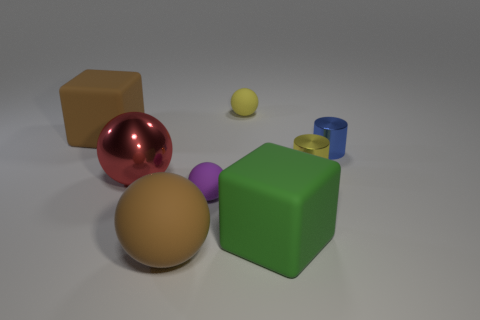Subtract all rubber spheres. How many spheres are left? 1 Subtract all yellow spheres. How many spheres are left? 3 Add 1 purple matte things. How many objects exist? 9 Subtract all green spheres. Subtract all blue cubes. How many spheres are left? 4 Subtract all cubes. How many objects are left? 6 Subtract all red things. Subtract all large red balls. How many objects are left? 6 Add 4 small matte balls. How many small matte balls are left? 6 Add 4 shiny spheres. How many shiny spheres exist? 5 Subtract 0 gray cubes. How many objects are left? 8 